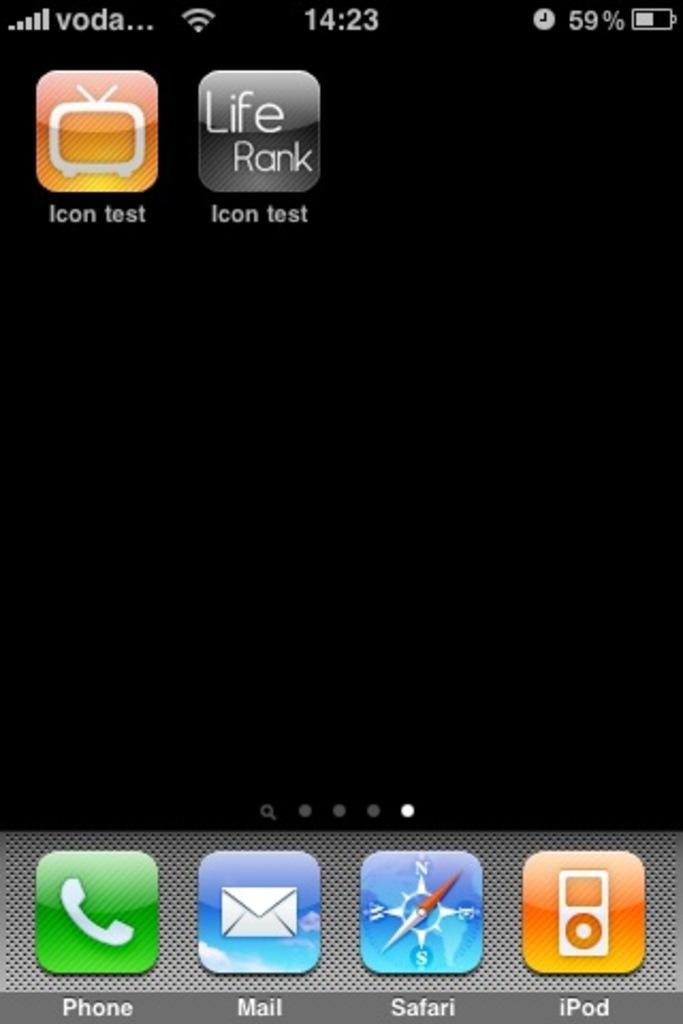<image>
Create a compact narrative representing the image presented. The screen of a phone shows basic apps at the bottom like mail and phone as well as test apps on top. 